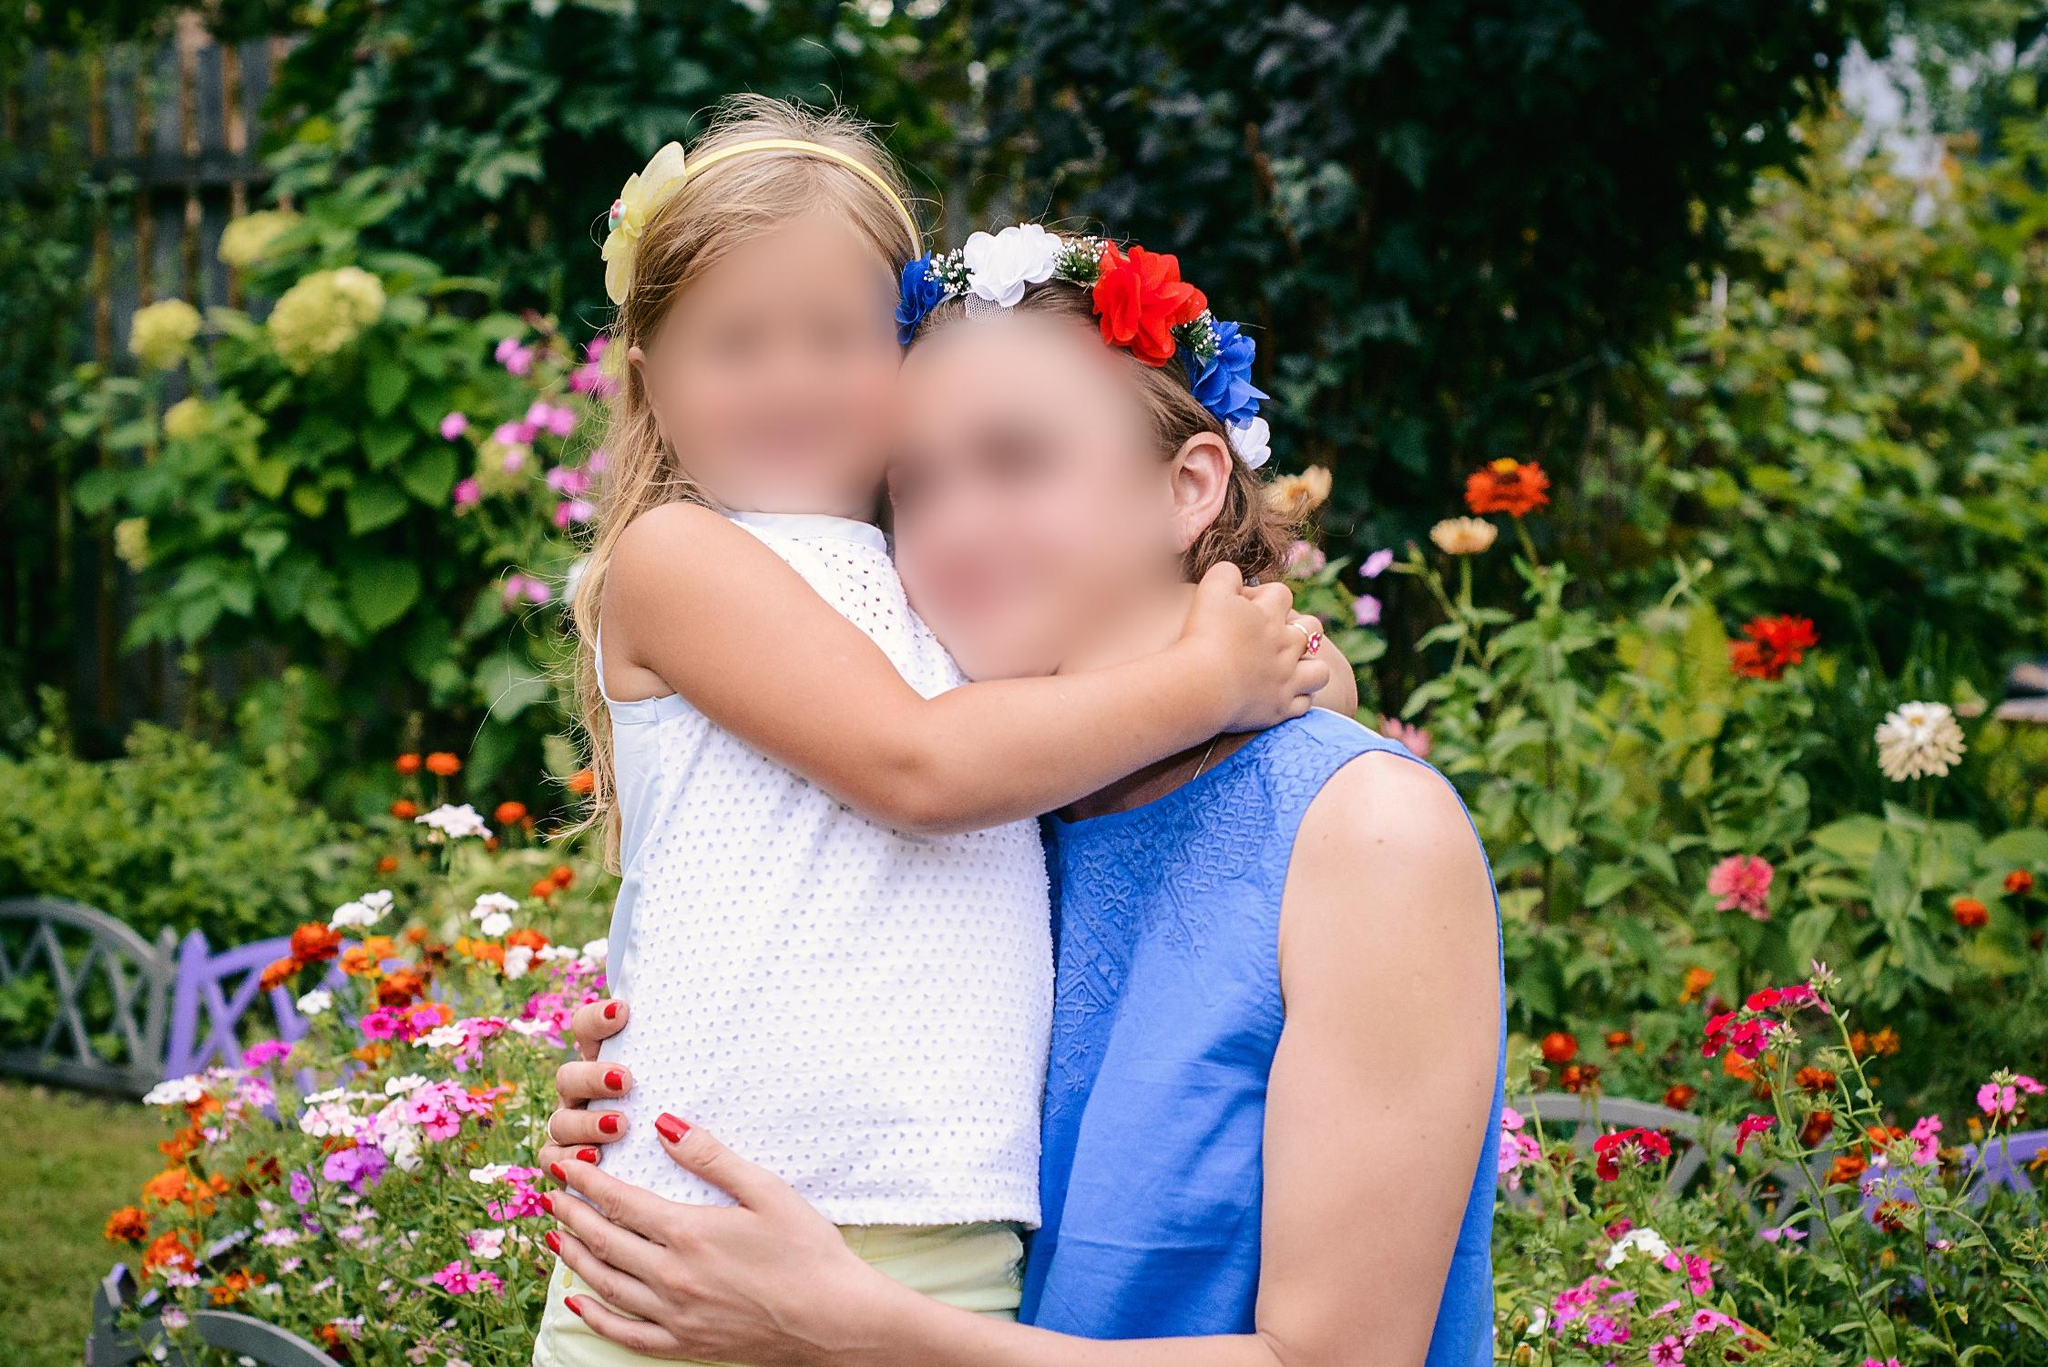What does this image suggest about the relationship between the two individuals? This image strongly suggests a close and affectionate relationship, likely familial. The embrace is warm and the younger individual seems to hold onto the older with comfort and affection, which is typical of close family bonds, such as that between a grandchild and grandparent or an aunt and her niece. 